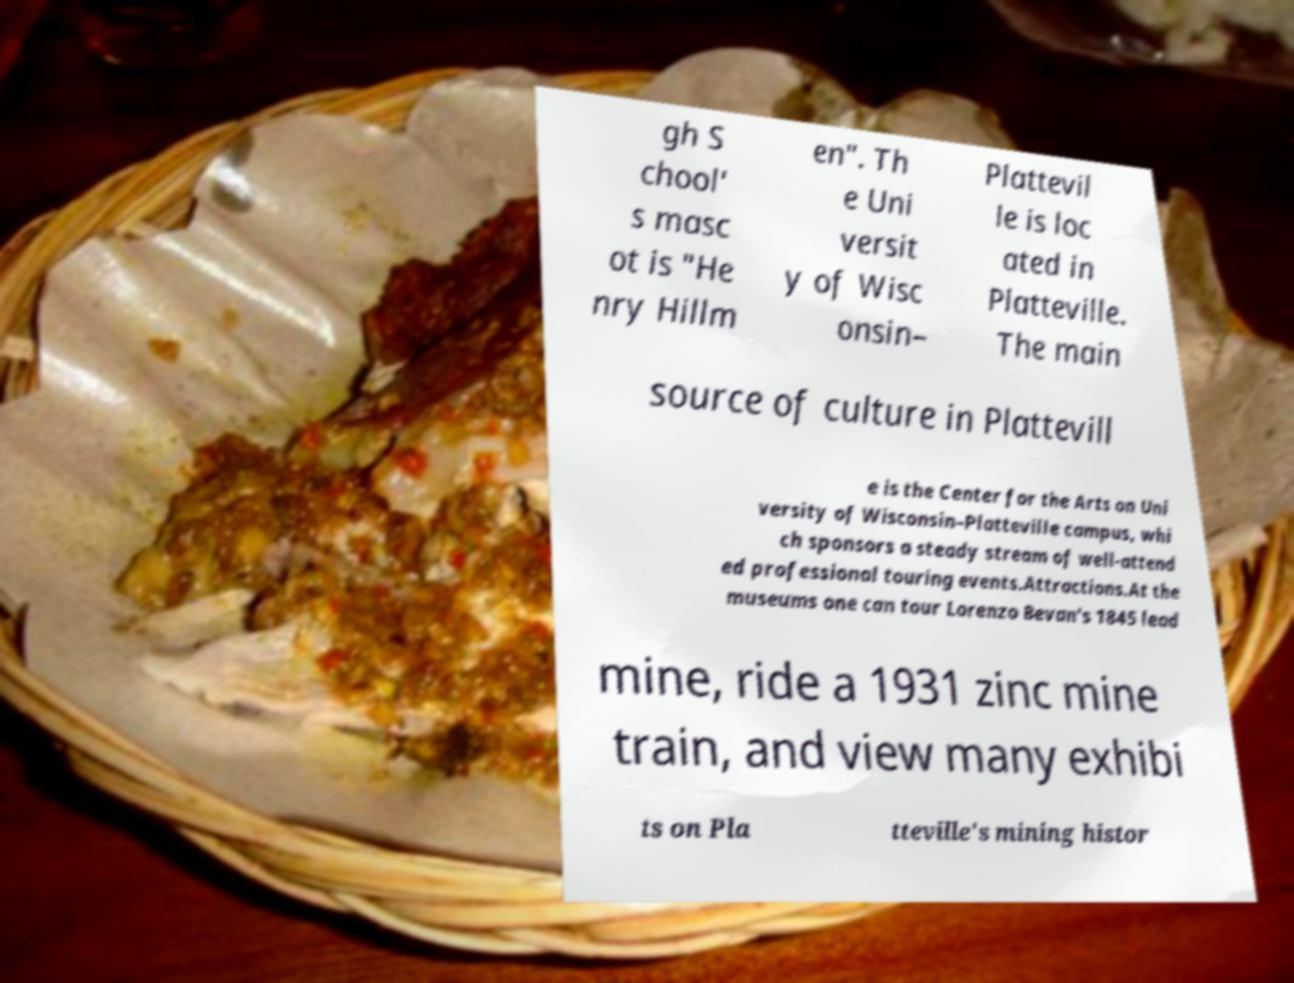For documentation purposes, I need the text within this image transcribed. Could you provide that? gh S chool' s masc ot is "He nry Hillm en". Th e Uni versit y of Wisc onsin– Plattevil le is loc ated in Platteville. The main source of culture in Plattevill e is the Center for the Arts on Uni versity of Wisconsin–Platteville campus, whi ch sponsors a steady stream of well-attend ed professional touring events.Attractions.At the museums one can tour Lorenzo Bevan's 1845 lead mine, ride a 1931 zinc mine train, and view many exhibi ts on Pla tteville's mining histor 